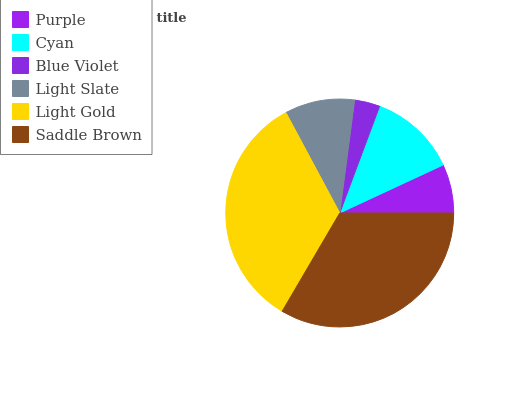Is Blue Violet the minimum?
Answer yes or no. Yes. Is Light Gold the maximum?
Answer yes or no. Yes. Is Cyan the minimum?
Answer yes or no. No. Is Cyan the maximum?
Answer yes or no. No. Is Cyan greater than Purple?
Answer yes or no. Yes. Is Purple less than Cyan?
Answer yes or no. Yes. Is Purple greater than Cyan?
Answer yes or no. No. Is Cyan less than Purple?
Answer yes or no. No. Is Cyan the high median?
Answer yes or no. Yes. Is Light Slate the low median?
Answer yes or no. Yes. Is Saddle Brown the high median?
Answer yes or no. No. Is Blue Violet the low median?
Answer yes or no. No. 